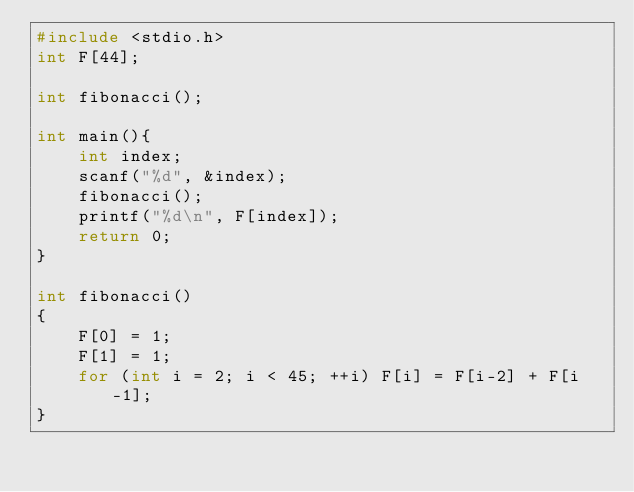<code> <loc_0><loc_0><loc_500><loc_500><_C_>#include <stdio.h>
int F[44];

int fibonacci();

int main(){
    int index;
    scanf("%d", &index);
    fibonacci();
    printf("%d\n", F[index]);
    return 0;
}

int fibonacci()
{
    F[0] = 1;
    F[1] = 1;
    for (int i = 2; i < 45; ++i) F[i] = F[i-2] + F[i-1];
}
</code> 